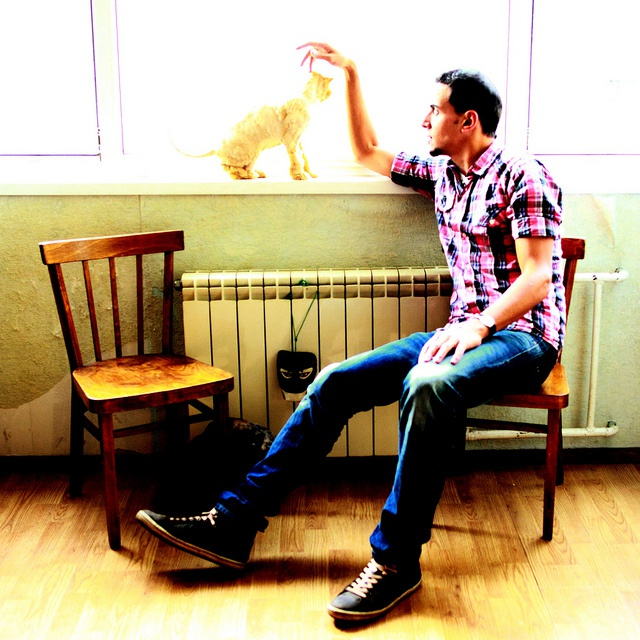Describe the objects in this image and their specific colors. I can see people in white, black, maroon, and violet tones, chair in white, black, maroon, olive, and tan tones, chair in white, black, maroon, and olive tones, backpack in white, black, maroon, olive, and gray tones, and cat in white, khaki, gold, ivory, and orange tones in this image. 